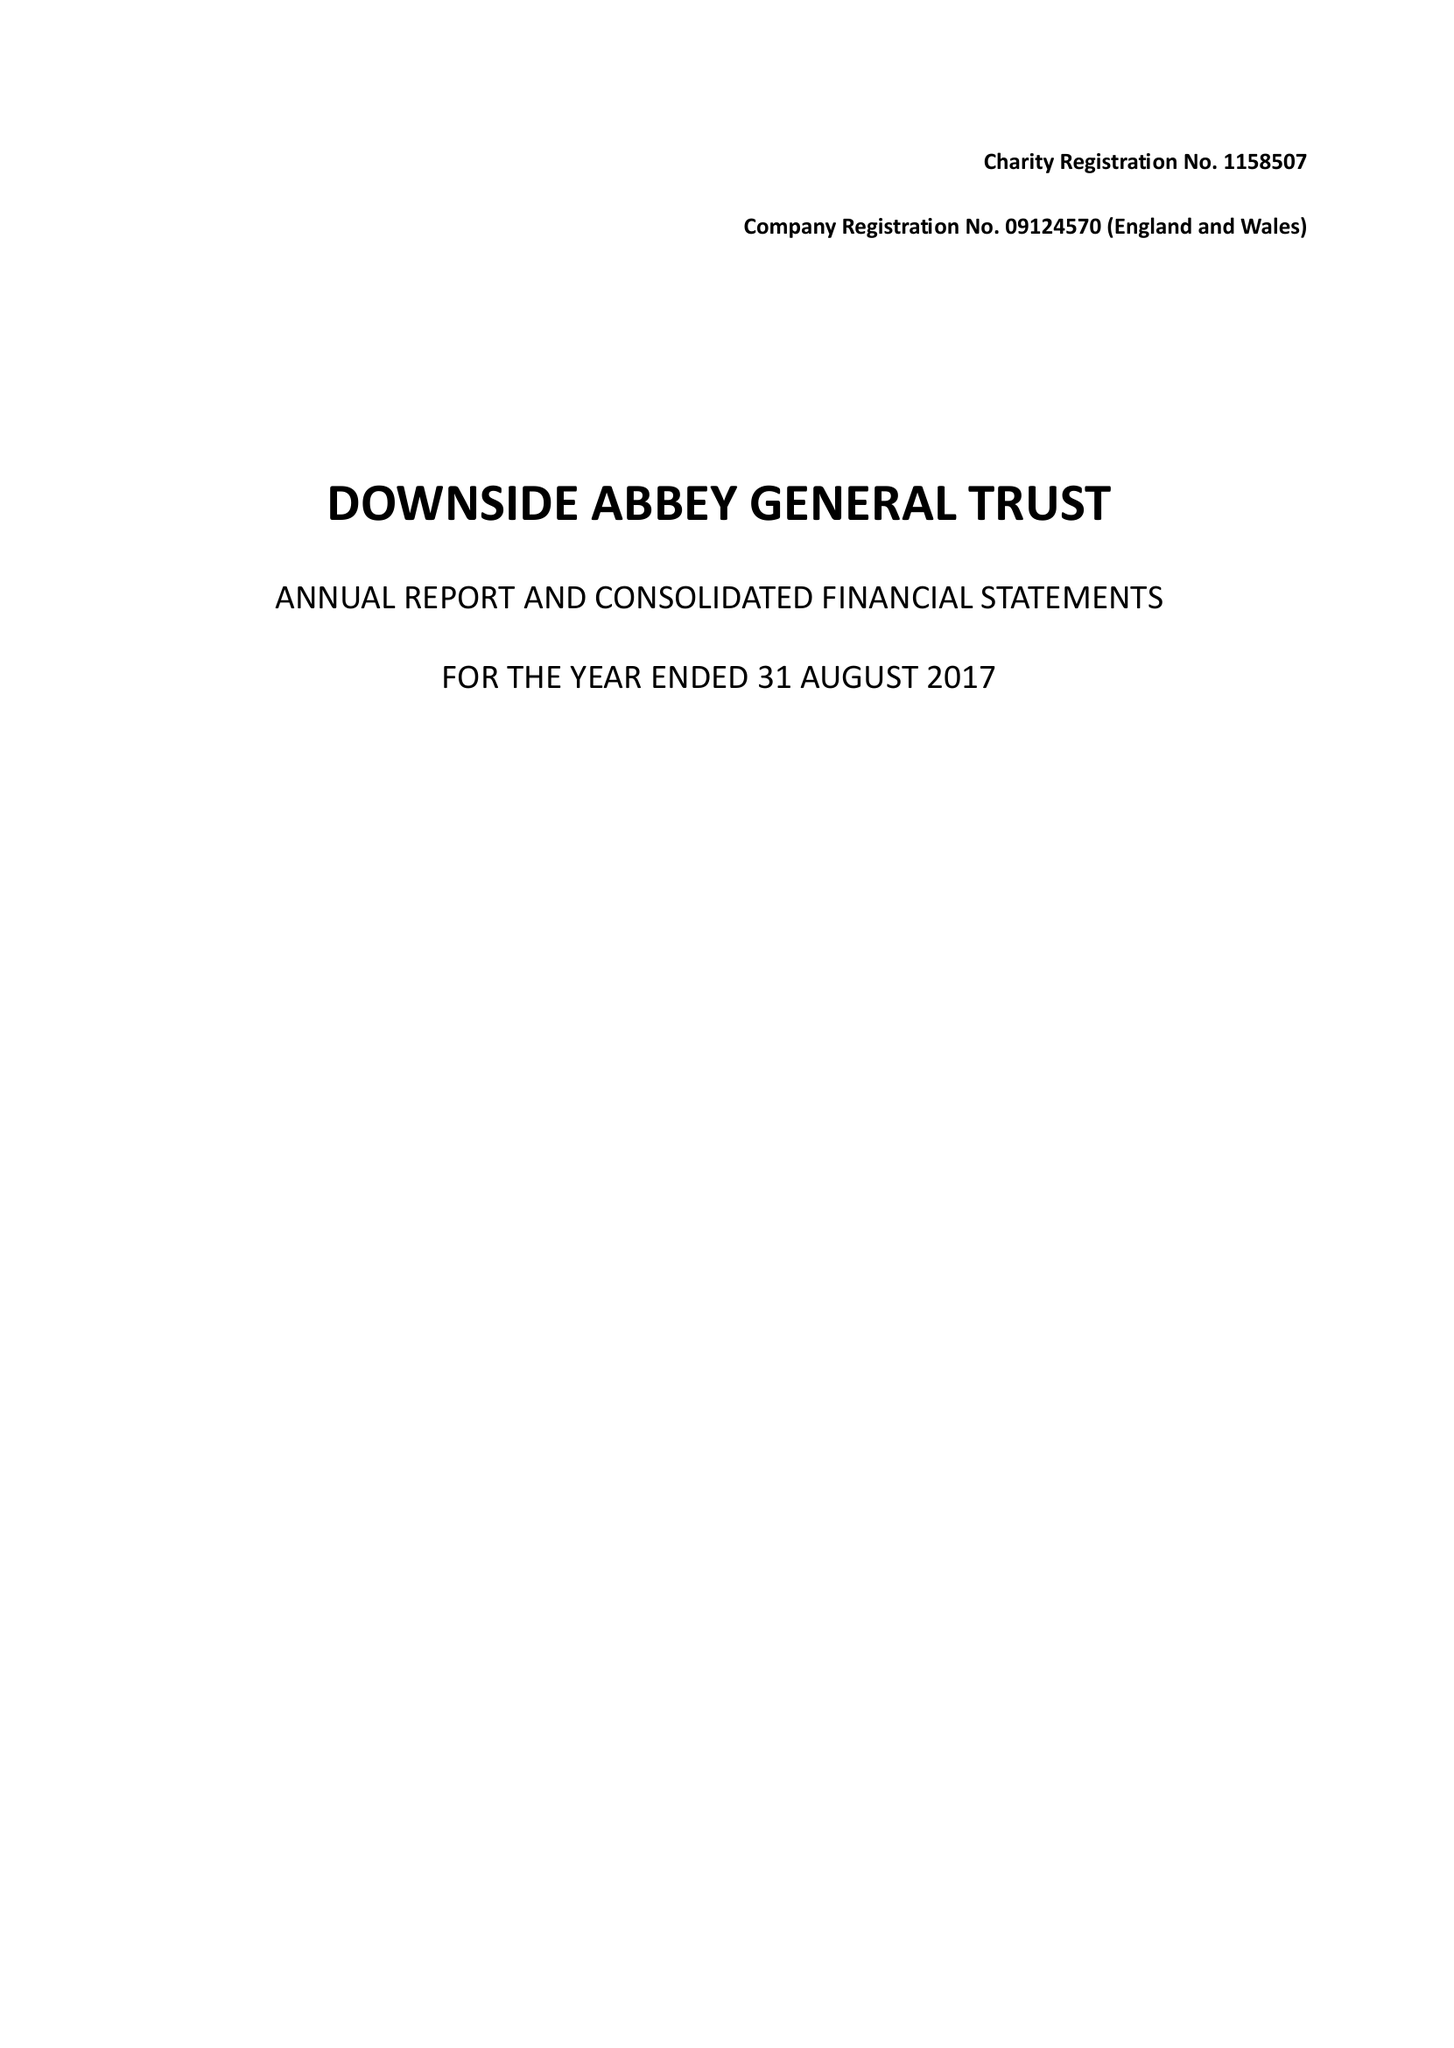What is the value for the report_date?
Answer the question using a single word or phrase. 2017-08-31 